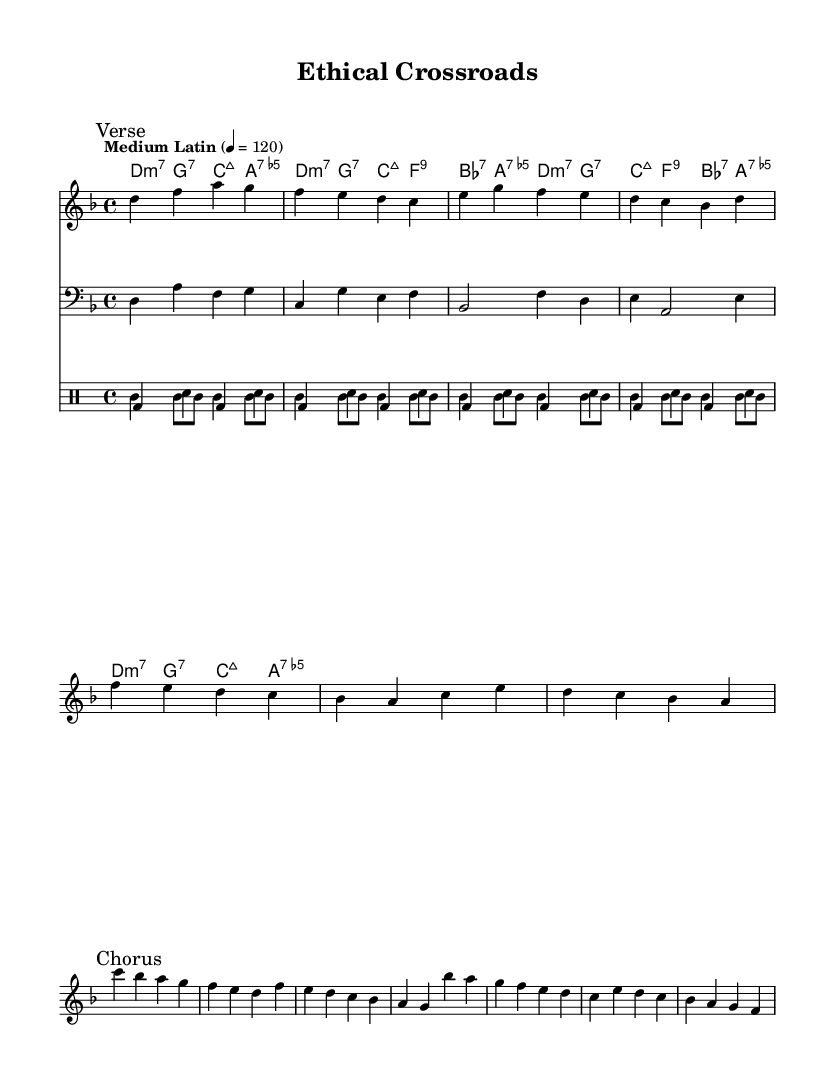What is the key signature of this piece? The key signature is D minor, which includes one flat (B flat) and indicates the tonal center of the piece.
Answer: D minor What is the time signature of this music? The time signature is 4/4, which means there are four beats in each measure and the quarter note receives one beat.
Answer: 4/4 What is the tempo marking for this music? The tempo marking is "Medium Latin," indicating a moderate Latin style tempo that typically around 120 beats per minute.
Answer: Medium Latin 120 How many measures are there in the chorus section? The chorus section contains four measures, as outlined in the melodic notation and chords associated with it.
Answer: Four measures What type of bass clef is used in this score? The score uses a standard bass clef, which indicates the range of notes typically played by bass instruments.
Answer: Bass clef What is the primary theme of the lyrics in this piece? The primary theme revolves around the ethical dilemmas faced in medical research, highlighting the tension between healing and loss.
Answer: Ethical dilemmas in medical research What musical elements contribute to this being classified as a fusion piece? The piece incorporates elements from Latin music rhythms (e.g., conga patterns) along with jazz harmonies (e.g., extended chords like major 7ths and 9ths) creating a blend characteristic of fusion genres.
Answer: Latin rhythms and jazz harmonies 